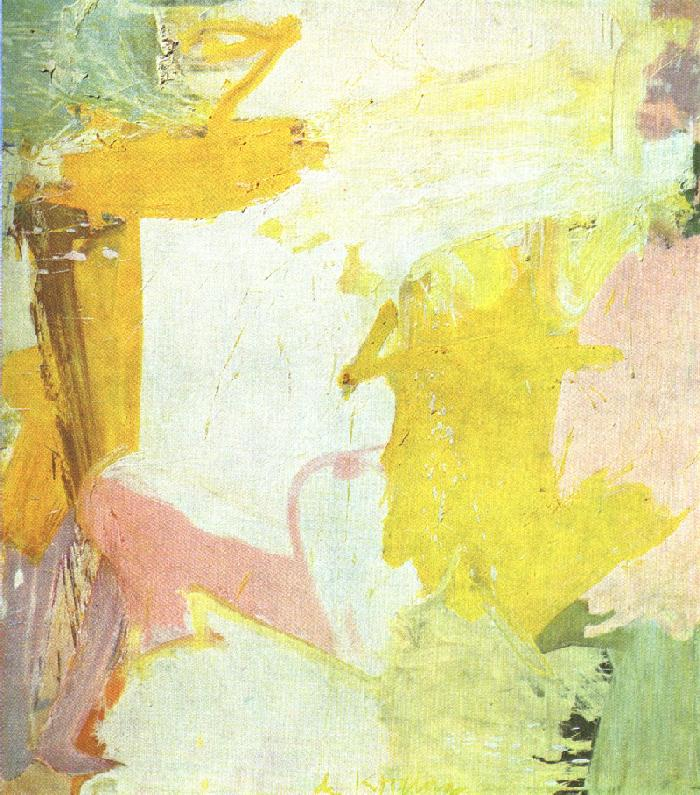What emotions do you think this painting could evoke in a viewer? This painting, with its soft pastel colors and flowing abstract forms, is likely to evoke a range of emotions. The light, airy quality of the artwork can inspire feelings of calmness and serenity. The gentle blending of yellow, pink, and white can also bring about a sense of warmth and comfort. For some viewers, the abstract nature of the piece might provoke curiosity and introspection, as they seek to find personal meaning within the shapes and colors. Overall, the painting's ethereal and fluid characteristics have the potential to evoke a peaceful and contemplative emotional response. Imagine you are inside the scene depicted by this painting. Describe your experience in detail. If I were inside the scene depicted by this painting, I would feel as if I were floating in a serene and dreamlike world. The air would be filled with a diffuse light, casting gentle hues of yellow and pink around me. The textures of the surroundings would be soft and inviting, with flowing, organic shapes that seem to move fluidly in a gentle breeze. There would be a sense of weightlessness, as if I were drifting through a warm and comforting atmosphere. The overall experience would be one of calmness, tranquility, and a profound connection to the abstract beauty of the world around me. 